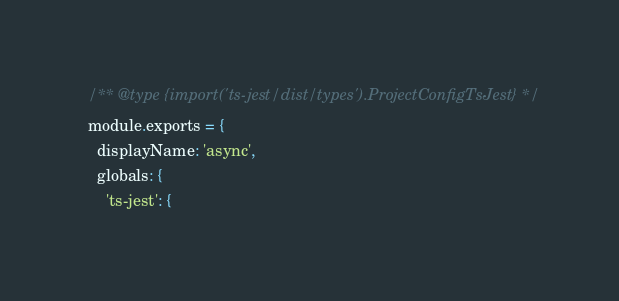Convert code to text. <code><loc_0><loc_0><loc_500><loc_500><_JavaScript_>/** @type {import('ts-jest/dist/types').ProjectConfigTsJest} */
module.exports = {
  displayName: 'async',
  globals: {
    'ts-jest': {</code> 